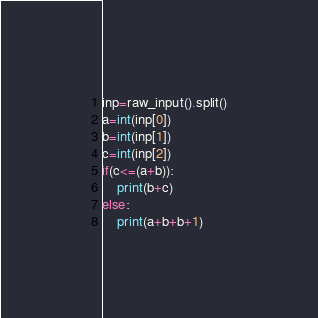Convert code to text. <code><loc_0><loc_0><loc_500><loc_500><_Python_>inp=raw_input().split()
a=int(inp[0])
b=int(inp[1])
c=int(inp[2])
if(c<=(a+b)):
	print(b+c)
else:
	print(a+b+b+1)
</code> 